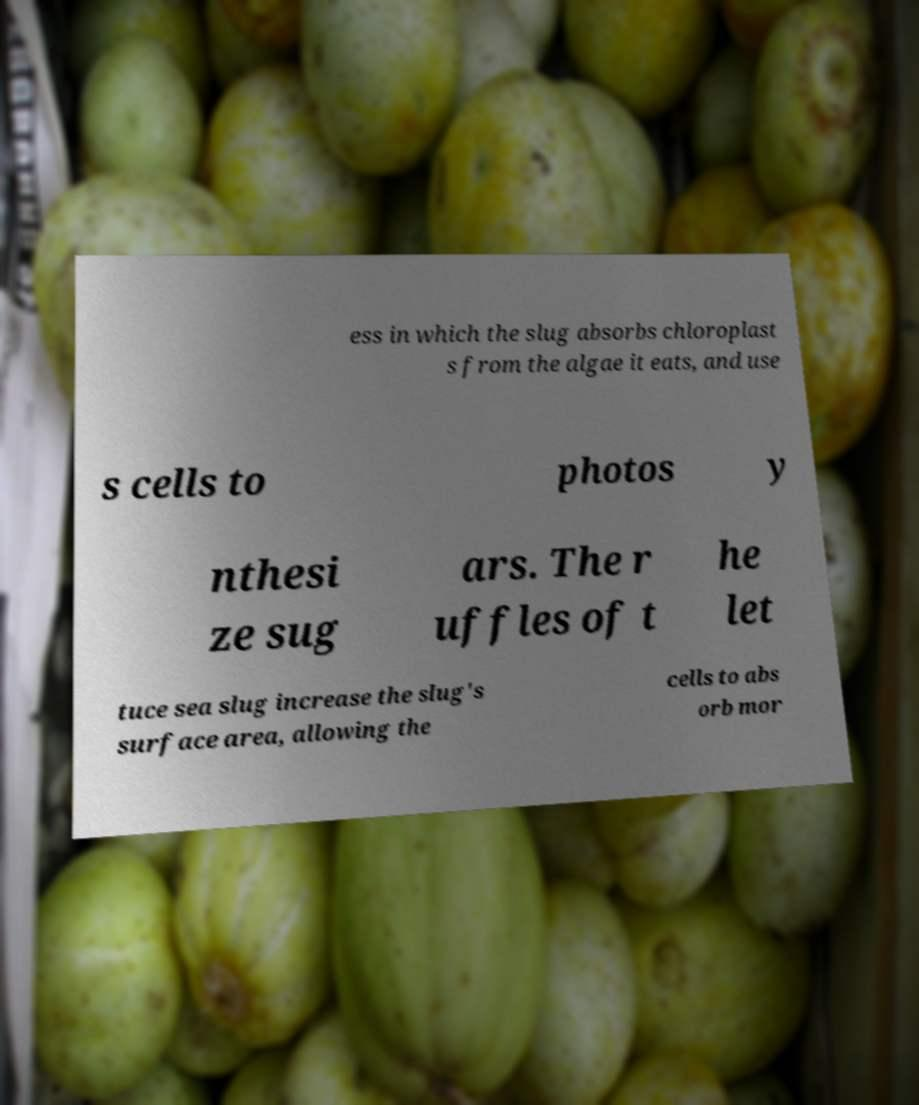Could you assist in decoding the text presented in this image and type it out clearly? ess in which the slug absorbs chloroplast s from the algae it eats, and use s cells to photos y nthesi ze sug ars. The r uffles of t he let tuce sea slug increase the slug's surface area, allowing the cells to abs orb mor 